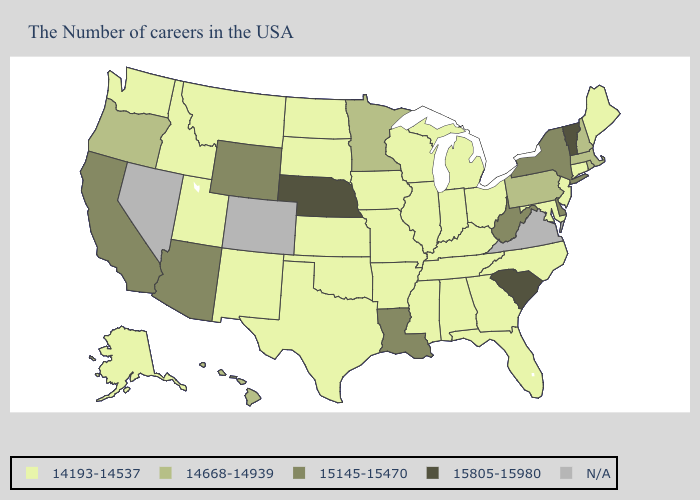Does Nebraska have the lowest value in the USA?
Give a very brief answer. No. What is the value of Maryland?
Concise answer only. 14193-14537. Among the states that border Georgia , does South Carolina have the lowest value?
Be succinct. No. What is the value of Louisiana?
Write a very short answer. 15145-15470. What is the value of Alaska?
Keep it brief. 14193-14537. Which states have the highest value in the USA?
Write a very short answer. Vermont, South Carolina, Nebraska. What is the highest value in the USA?
Be succinct. 15805-15980. Is the legend a continuous bar?
Concise answer only. No. What is the value of Minnesota?
Be succinct. 14668-14939. Does South Carolina have the highest value in the USA?
Quick response, please. Yes. Which states have the lowest value in the MidWest?
Keep it brief. Ohio, Michigan, Indiana, Wisconsin, Illinois, Missouri, Iowa, Kansas, South Dakota, North Dakota. 